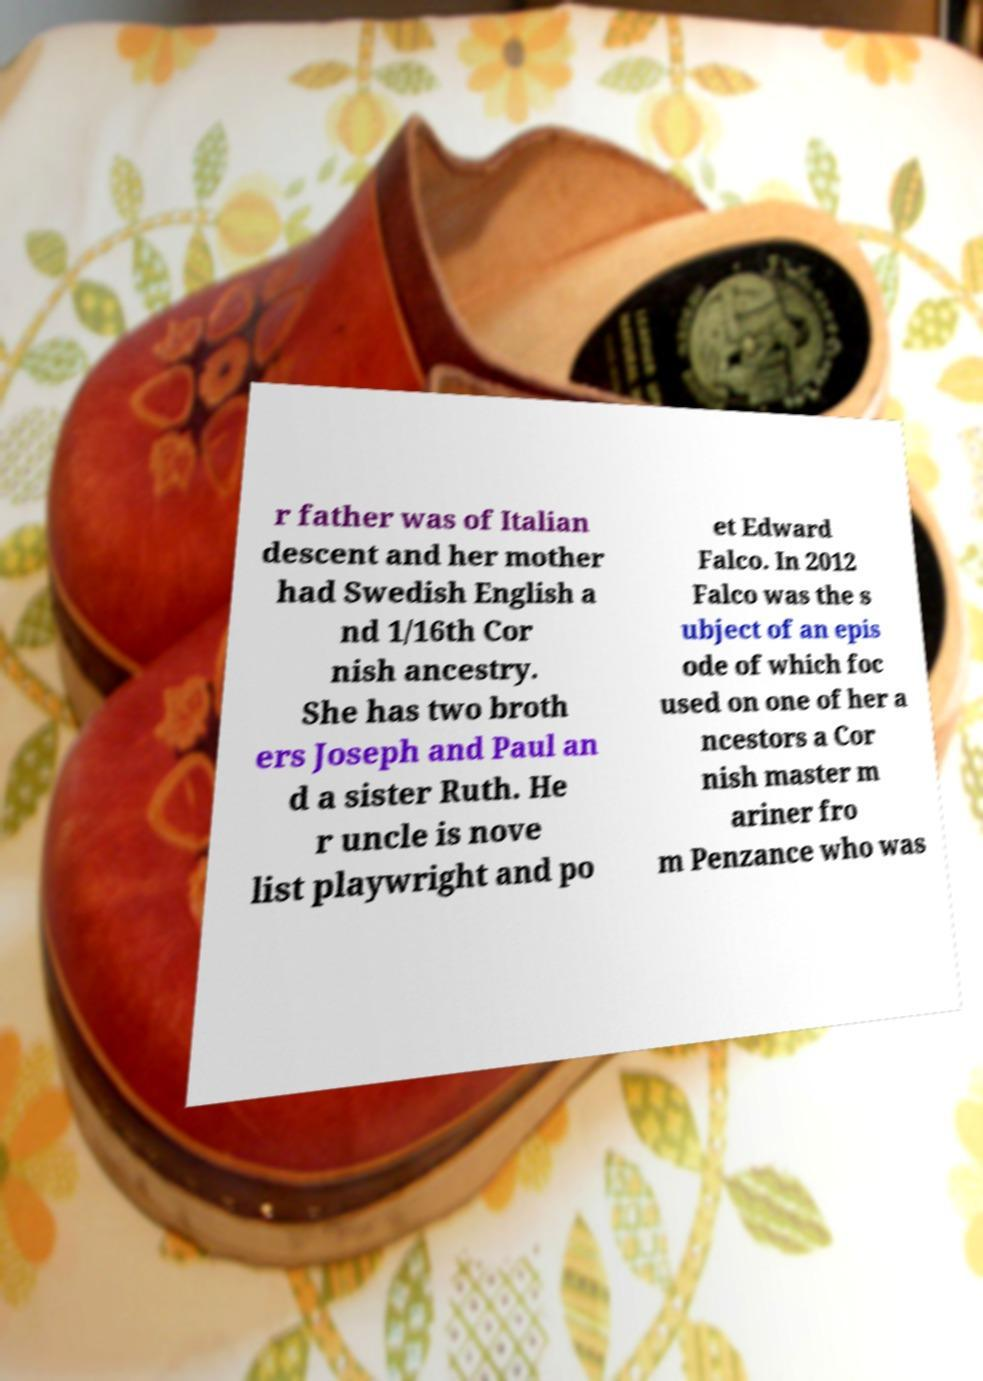For documentation purposes, I need the text within this image transcribed. Could you provide that? r father was of Italian descent and her mother had Swedish English a nd 1/16th Cor nish ancestry. She has two broth ers Joseph and Paul an d a sister Ruth. He r uncle is nove list playwright and po et Edward Falco. In 2012 Falco was the s ubject of an epis ode of which foc used on one of her a ncestors a Cor nish master m ariner fro m Penzance who was 